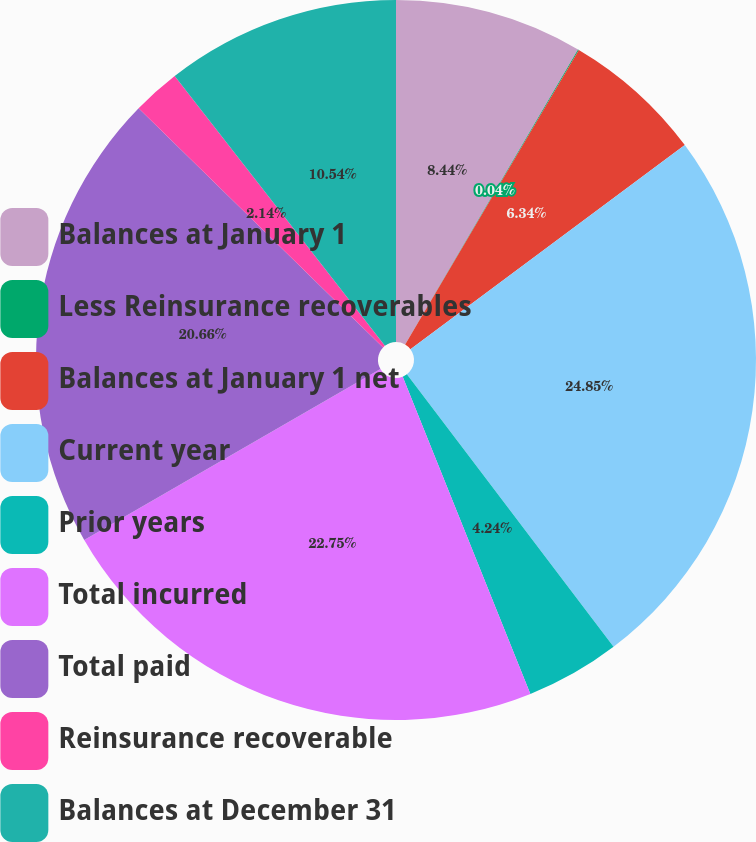Convert chart. <chart><loc_0><loc_0><loc_500><loc_500><pie_chart><fcel>Balances at January 1<fcel>Less Reinsurance recoverables<fcel>Balances at January 1 net<fcel>Current year<fcel>Prior years<fcel>Total incurred<fcel>Total paid<fcel>Reinsurance recoverable<fcel>Balances at December 31<nl><fcel>8.44%<fcel>0.04%<fcel>6.34%<fcel>24.86%<fcel>4.24%<fcel>22.76%<fcel>20.66%<fcel>2.14%<fcel>10.54%<nl></chart> 